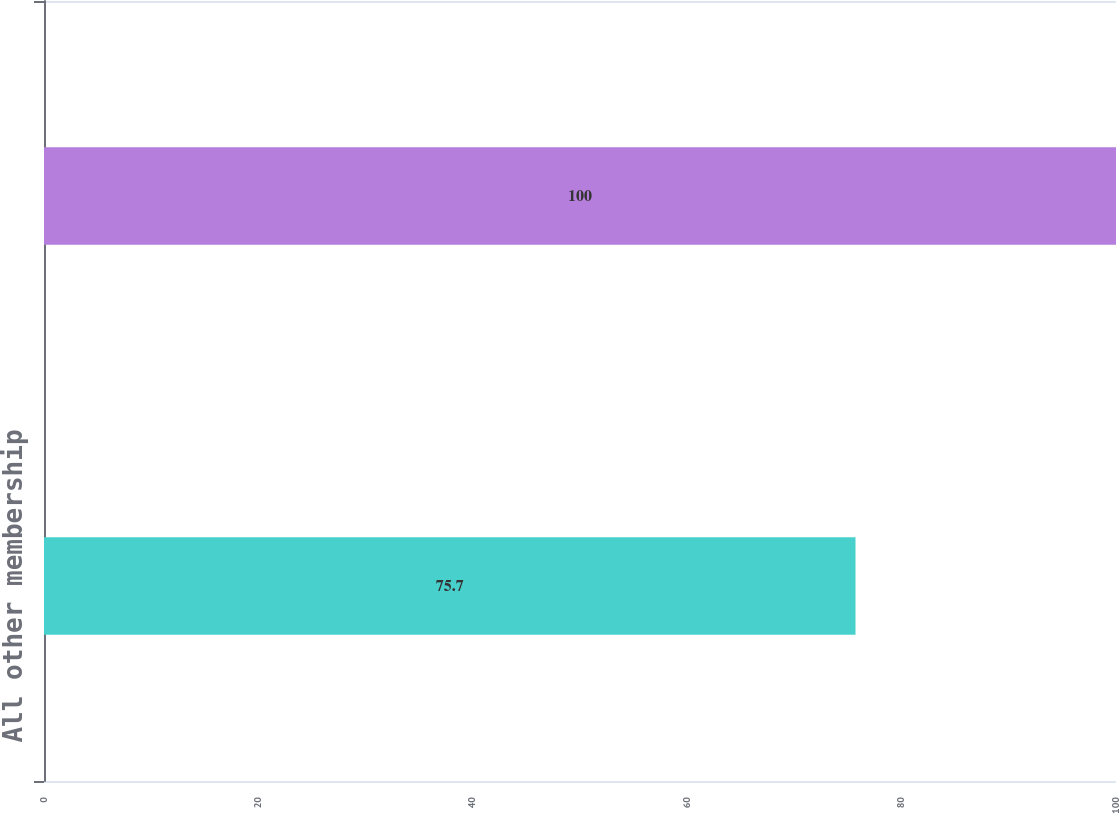Convert chart to OTSL. <chart><loc_0><loc_0><loc_500><loc_500><bar_chart><fcel>All other membership<fcel>Total<nl><fcel>75.7<fcel>100<nl></chart> 